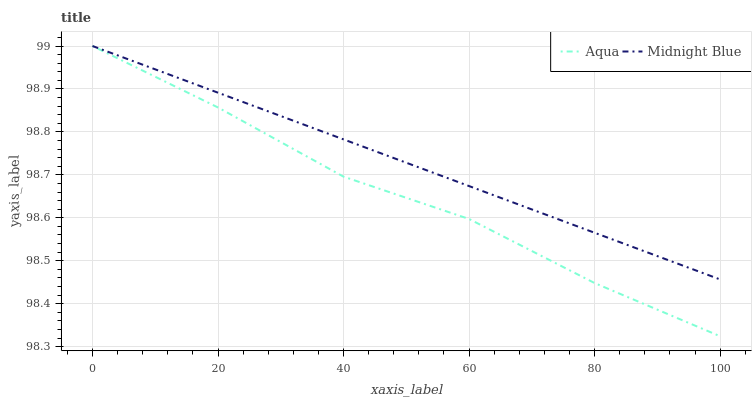Does Aqua have the minimum area under the curve?
Answer yes or no. Yes. Does Midnight Blue have the maximum area under the curve?
Answer yes or no. Yes. Does Midnight Blue have the minimum area under the curve?
Answer yes or no. No. Is Midnight Blue the smoothest?
Answer yes or no. Yes. Is Aqua the roughest?
Answer yes or no. Yes. Is Midnight Blue the roughest?
Answer yes or no. No. Does Aqua have the lowest value?
Answer yes or no. Yes. Does Midnight Blue have the lowest value?
Answer yes or no. No. Does Midnight Blue have the highest value?
Answer yes or no. Yes. Does Aqua intersect Midnight Blue?
Answer yes or no. Yes. Is Aqua less than Midnight Blue?
Answer yes or no. No. Is Aqua greater than Midnight Blue?
Answer yes or no. No. 